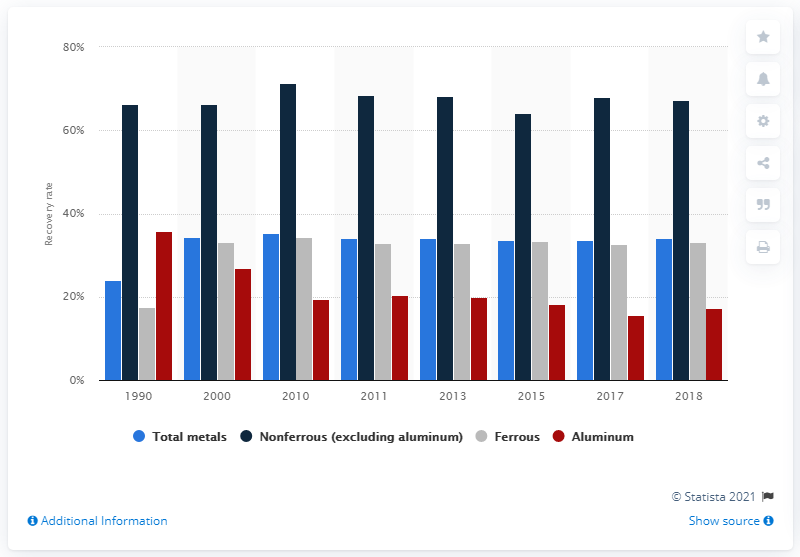List a handful of essential elements in this visual. In 2018, the recycling rate of aluminum was 17.2%. According to data from 2018, 34.1% of metal waste was successfully recycled. 